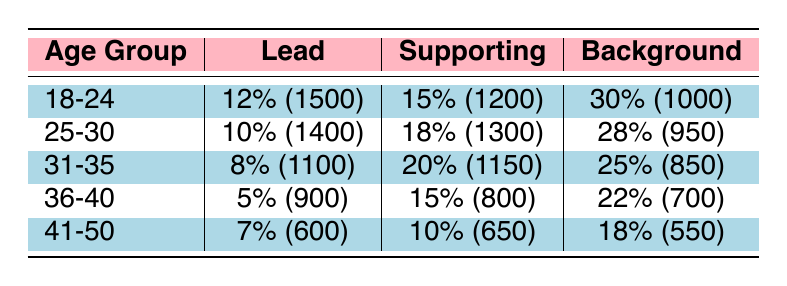What is the audition success rate for actresses aged 18-24 for lead roles? The table shows that the success rate for lead roles in the age group 18-24 is 12%.
Answer: 12% Which age group has the highest success rate for supporting roles? According to the table, the age group 31-35 has the highest success rate for supporting roles at 20%.
Answer: 31-35 How many auditions were conducted for background roles for actresses aged 41-50? The table indicates that there were 550 auditions for background roles in the age group 41-50.
Answer: 550 What is the total number of auditions for actresses aged 25-30? To find the total, sum the number of auditions for all role types in that age group: 1400 (lead) + 1300 (supporting) + 950 (background) = 3650.
Answer: 3650 Is the success rate for background roles higher for the age group 18-24 than for 36-40? The background success rate for age group 18-24 is 30% while it is 22% for 36-40, so yes, it is higher for 18-24.
Answer: Yes What is the average success rate for all role types in the age group 25-30? The average success rate is calculated as (10% + 18% + 28%) / 3 = 18.67%.
Answer: 18.67% Which age group has the lowest success rate for lead roles? According to the table, the age group 36-40 has the lowest success rate for lead roles at 5%.
Answer: 36-40 What is the difference in the number of auditions between 18-24 and 41-50 age groups for supporting roles? The number of auditions for 18-24 supporting roles is 1200, and for 41-50 it is 650. The difference is 1200 - 650 = 550.
Answer: 550 Is it true that the success rate for lead roles decreases as the age group increases? Looking at the table, the success rates for lead roles are 12%, 10%, 8%, 5%, and 7% for the age groups 18-24, 25-30, 31-35, 36-40, and 41-50 respectively, showing a general decrease but then an increase from 36-40 to 41-50. Therefore, this statement is false.
Answer: No What is the total success rate for all types of roles in the age group 31-35? Total success rate is calculated as (8% + 20% + 25%) = 53%.
Answer: 53% 